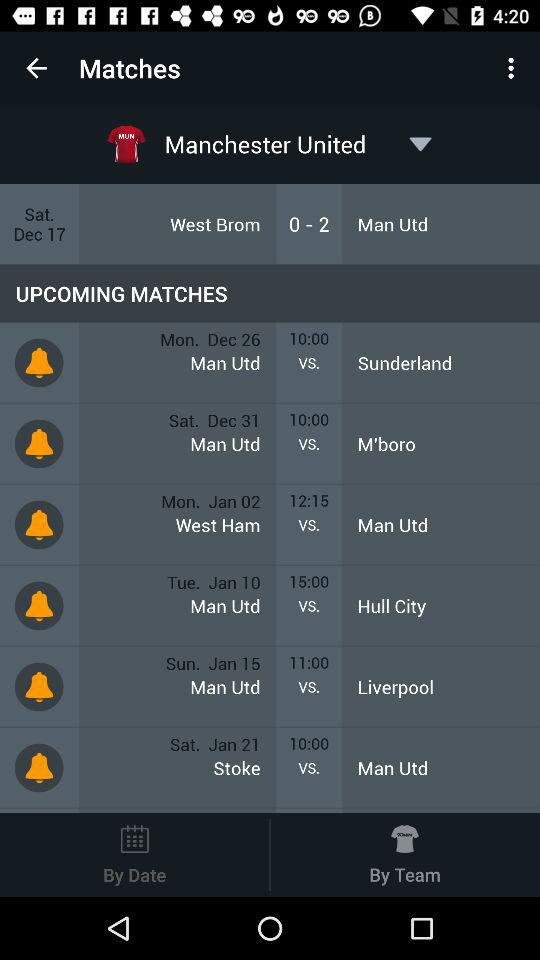How many more goals did Manchester United score than West Brom?
Answer the question using a single word or phrase. 2 